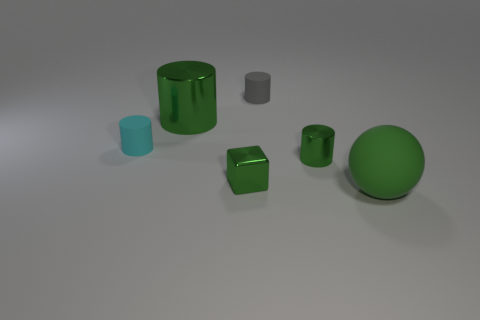Subtract all green cylinders. How many were subtracted if there are1green cylinders left? 1 Add 3 small shiny cubes. How many objects exist? 9 Subtract all gray cylinders. How many cylinders are left? 3 Subtract all gray cylinders. How many cylinders are left? 3 Add 6 small spheres. How many small spheres exist? 6 Subtract 0 cyan spheres. How many objects are left? 6 Subtract all blocks. How many objects are left? 5 Subtract 2 cylinders. How many cylinders are left? 2 Subtract all cyan cylinders. Subtract all red balls. How many cylinders are left? 3 Subtract all yellow cylinders. How many brown balls are left? 0 